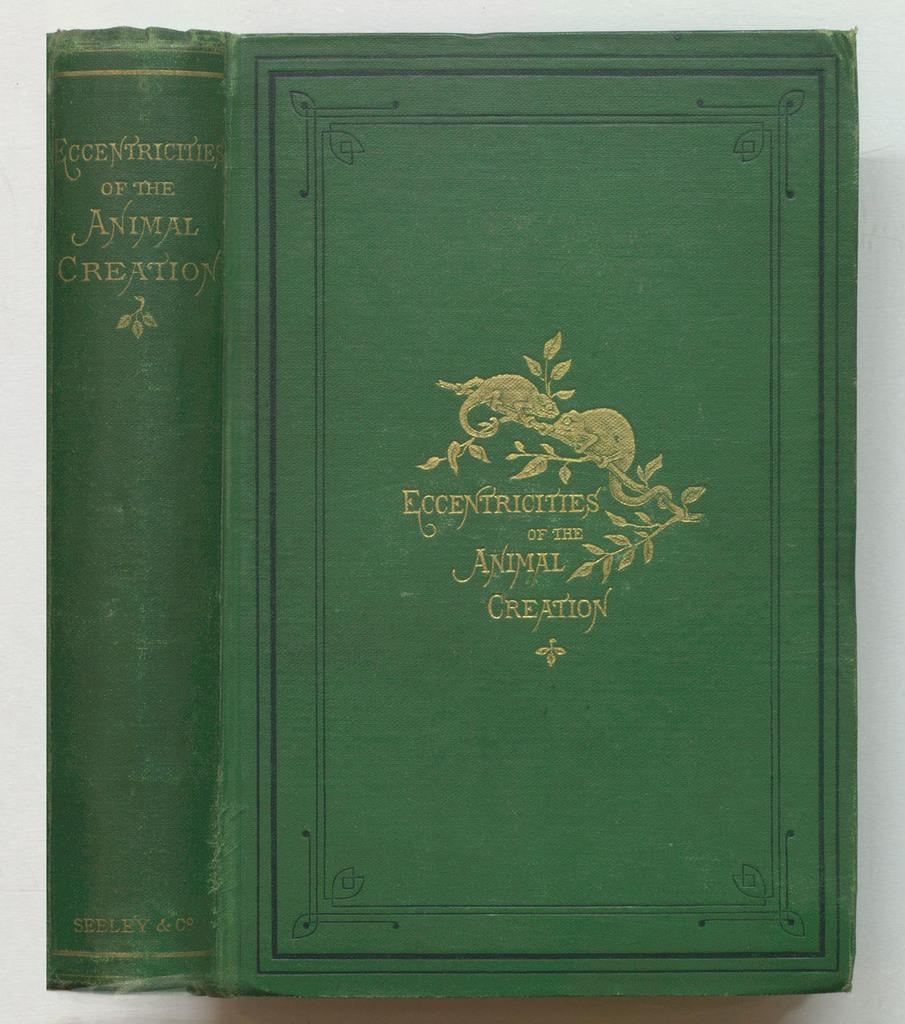<image>
Create a compact narrative representing the image presented. Two gold iguanas balance on a branch above the book title Eccentricities of the Animal Creation. 